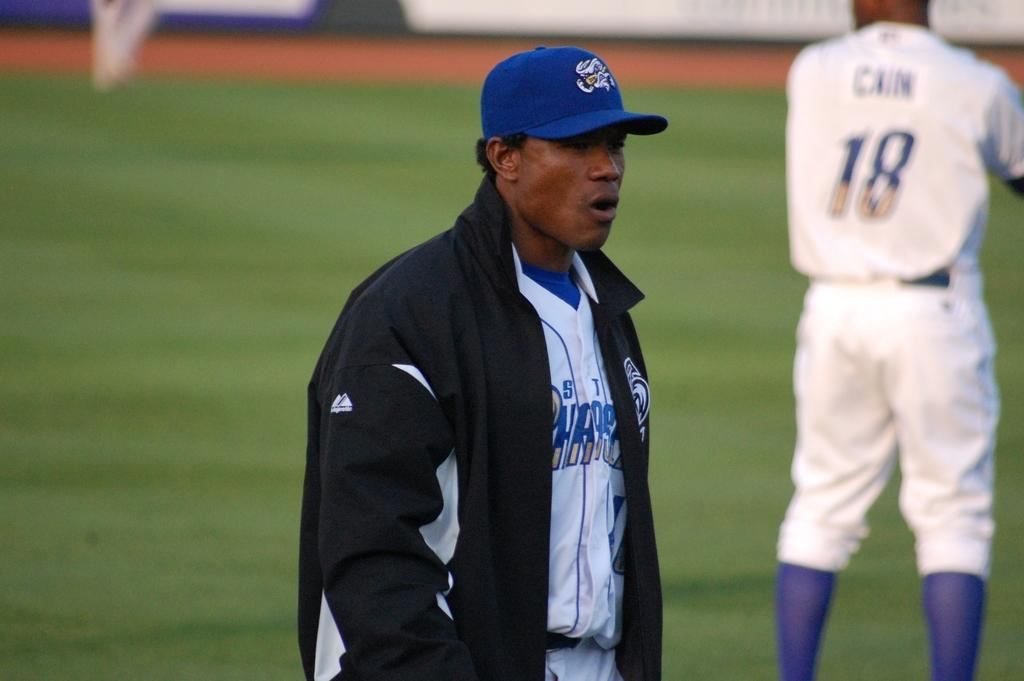<image>
Give a short and clear explanation of the subsequent image. A baseball player is wearing a jacket on the field with the player on the right having 18 CAIN on the back of his uniform. 